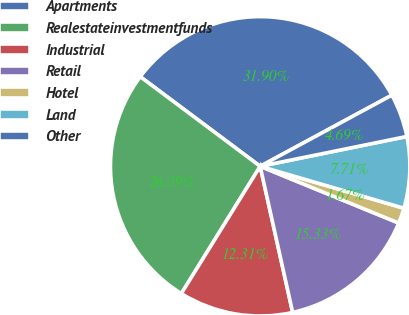<chart> <loc_0><loc_0><loc_500><loc_500><pie_chart><fcel>Apartments<fcel>Realestateinvestmentfunds<fcel>Industrial<fcel>Retail<fcel>Hotel<fcel>Land<fcel>Other<nl><fcel>31.9%<fcel>26.39%<fcel>12.31%<fcel>15.33%<fcel>1.67%<fcel>7.71%<fcel>4.69%<nl></chart> 